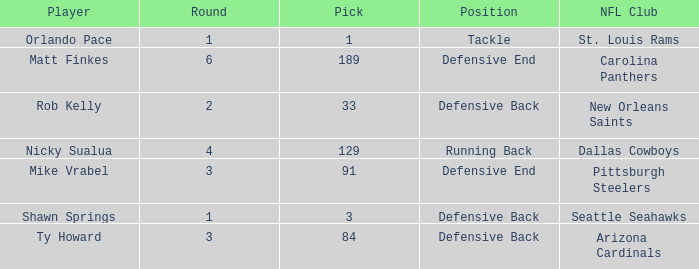What lowest round has orlando pace as the player? 1.0. 